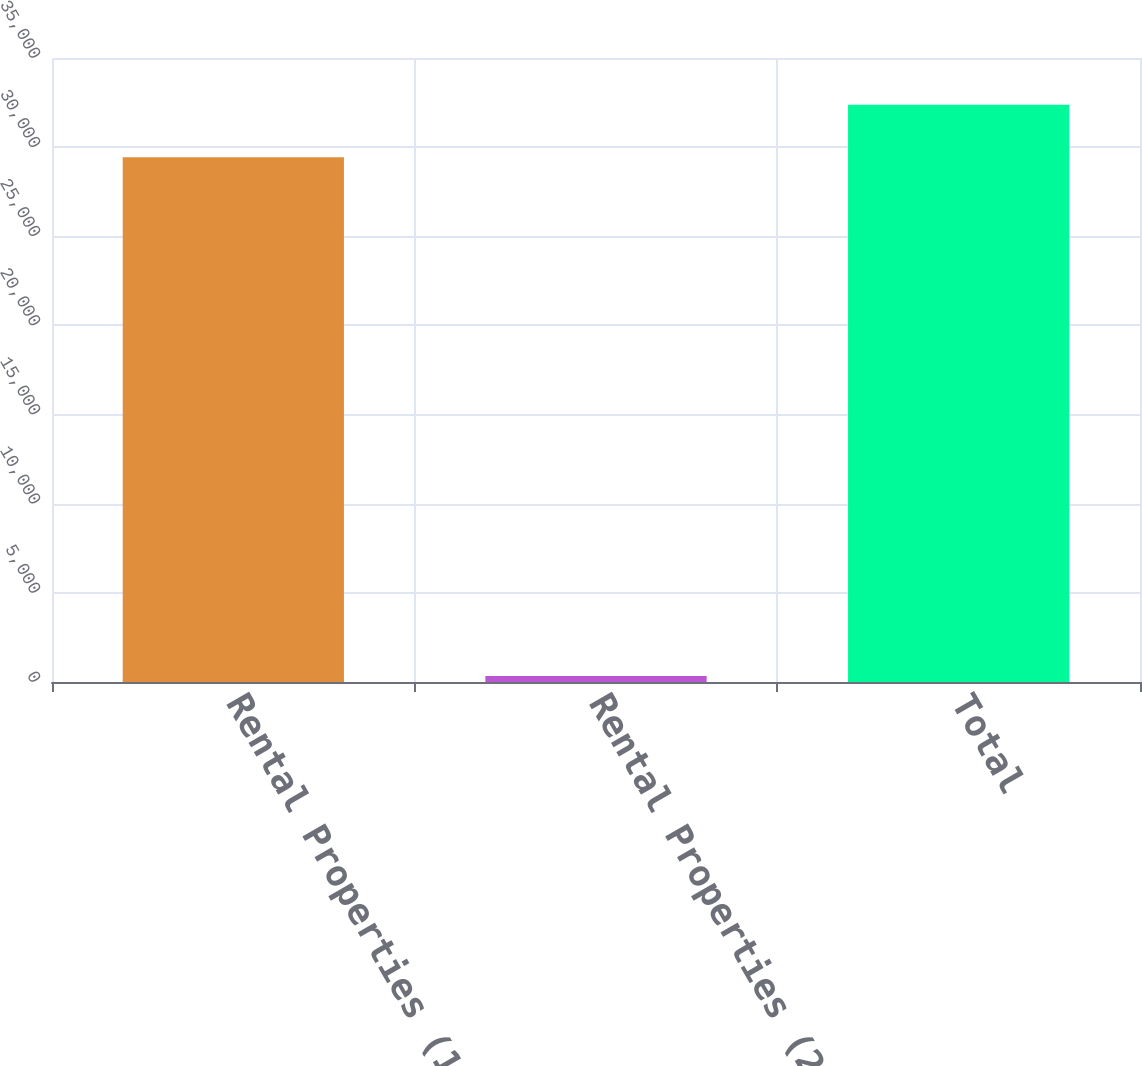Convert chart. <chart><loc_0><loc_0><loc_500><loc_500><bar_chart><fcel>Rental Properties (1)<fcel>Rental Properties (2)<fcel>Total<nl><fcel>29440<fcel>336<fcel>32384<nl></chart> 